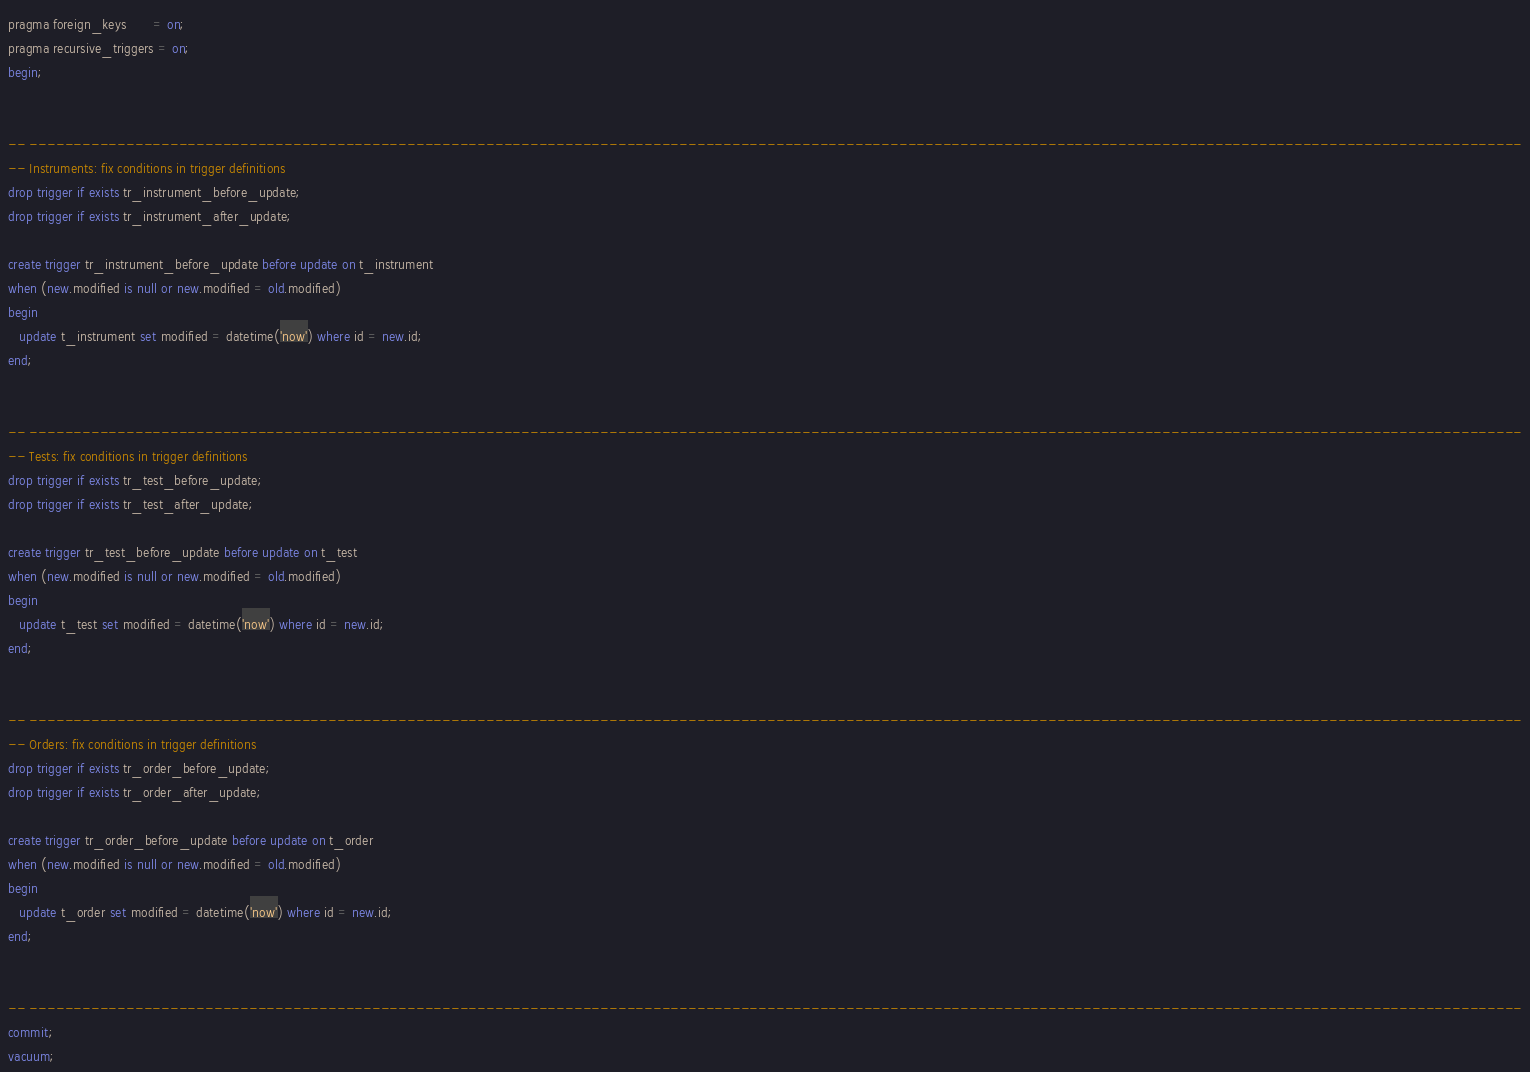Convert code to text. <code><loc_0><loc_0><loc_500><loc_500><_SQL_>
pragma foreign_keys       = on;
pragma recursive_triggers = on;
begin;


-- --------------------------------------------------------------------------------------------------------------------------------------------------------------------------
-- Instruments: fix conditions in trigger definitions
drop trigger if exists tr_instrument_before_update;
drop trigger if exists tr_instrument_after_update;

create trigger tr_instrument_before_update before update on t_instrument
when (new.modified is null or new.modified = old.modified)
begin
   update t_instrument set modified = datetime('now') where id = new.id;
end;


-- --------------------------------------------------------------------------------------------------------------------------------------------------------------------------
-- Tests: fix conditions in trigger definitions
drop trigger if exists tr_test_before_update;
drop trigger if exists tr_test_after_update;

create trigger tr_test_before_update before update on t_test
when (new.modified is null or new.modified = old.modified)
begin
   update t_test set modified = datetime('now') where id = new.id;
end;


-- --------------------------------------------------------------------------------------------------------------------------------------------------------------------------
-- Orders: fix conditions in trigger definitions
drop trigger if exists tr_order_before_update;
drop trigger if exists tr_order_after_update;

create trigger tr_order_before_update before update on t_order
when (new.modified is null or new.modified = old.modified)
begin
   update t_order set modified = datetime('now') where id = new.id;
end;


-- --------------------------------------------------------------------------------------------------------------------------------------------------------------------------
commit;
vacuum;
</code> 